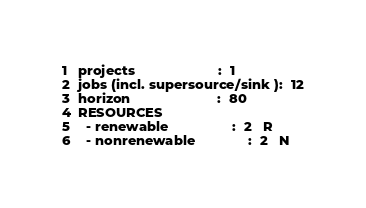Convert code to text. <code><loc_0><loc_0><loc_500><loc_500><_ObjectiveC_>projects                      :  1
jobs (incl. supersource/sink ):  12
horizon                       :  80
RESOURCES
  - renewable                 :  2   R
  - nonrenewable              :  2   N</code> 